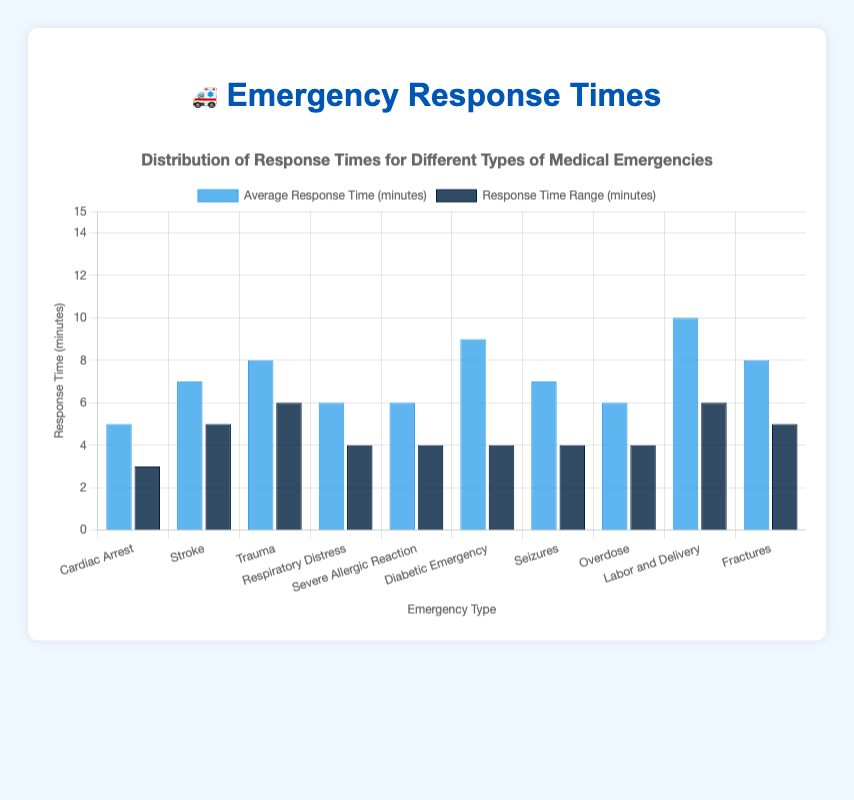Which medical emergency has the shortest average response time? The bar representing the average response time for "Cardiac Arrest" is the shortest.
Answer: Cardiac Arrest Which medical emergency has the longest average response time? The bar representing the average response time for "Labor and Delivery" is the tallest.
Answer: Labor and Delivery What is the average response time for Stroke? The bar labeled "Stroke" indicates the average response time is 7 minutes.
Answer: 7 minutes Which emergency types have an average response time of 6 minutes? The bars for "Respiratory Distress," "Severe Allergic Reaction," and "Overdose" are at the 6-minute mark.
Answer: Respiratory Distress, Severe Allergic Reaction, Overdose How much longer is the average response time for Diabetic Emergency compared to Cardiac Arrest? Subtract the average response time of Cardiac Arrest (5 minutes) from Diabetic Emergency (9 minutes): 9 - 5 = 4 minutes.
Answer: 4 minutes What is the range of response times for Trauma? The label indicates the range is 6-12 minutes.
Answer: 6-12 minutes Which medical emergency has both a higher average response time and a wider response time range compared to Overdose? Compare each emergency type: "Trauma" fits as it has an average response time (8 minutes) higher than Overdose (6 minutes) and a wider range (6-12 minutes vs 4-8).
Answer: Trauma Which medical emergency has the same response time range as Severe Allergic Reaction but a different average response time? "Overdose" has the same range (4-8 minutes) but a different average response time.
Answer: Overdose Which emergency type’s response time range has the widest range, and what is the width of this range? The bar for "Labor and Delivery" has the widest range (7-13 minutes). The width is 13 - 7 = 6 minutes.
Answer: Labor and Delivery, 6 minutes 